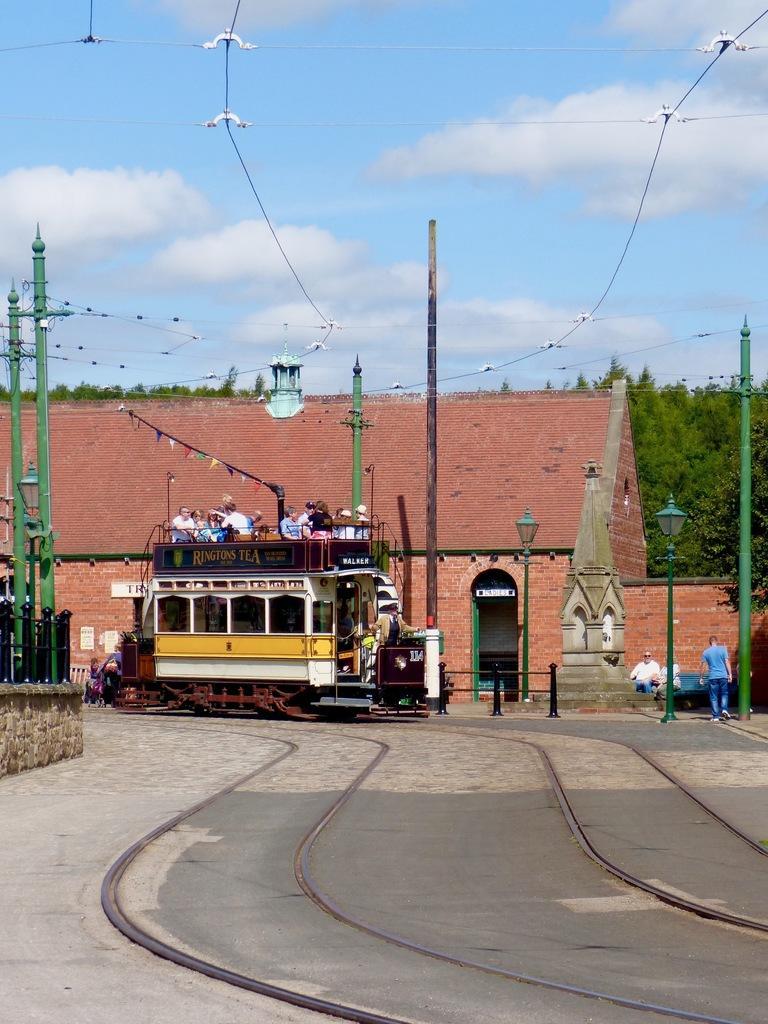Describe this image in one or two sentences. In this image we can see some people inside a motor vehicle which is on the track. On the right side we can see some people standing. we can also see a house with a roof, street lights, poles with wires and some trees. On the backside we can see the sky which looks cloudy. 